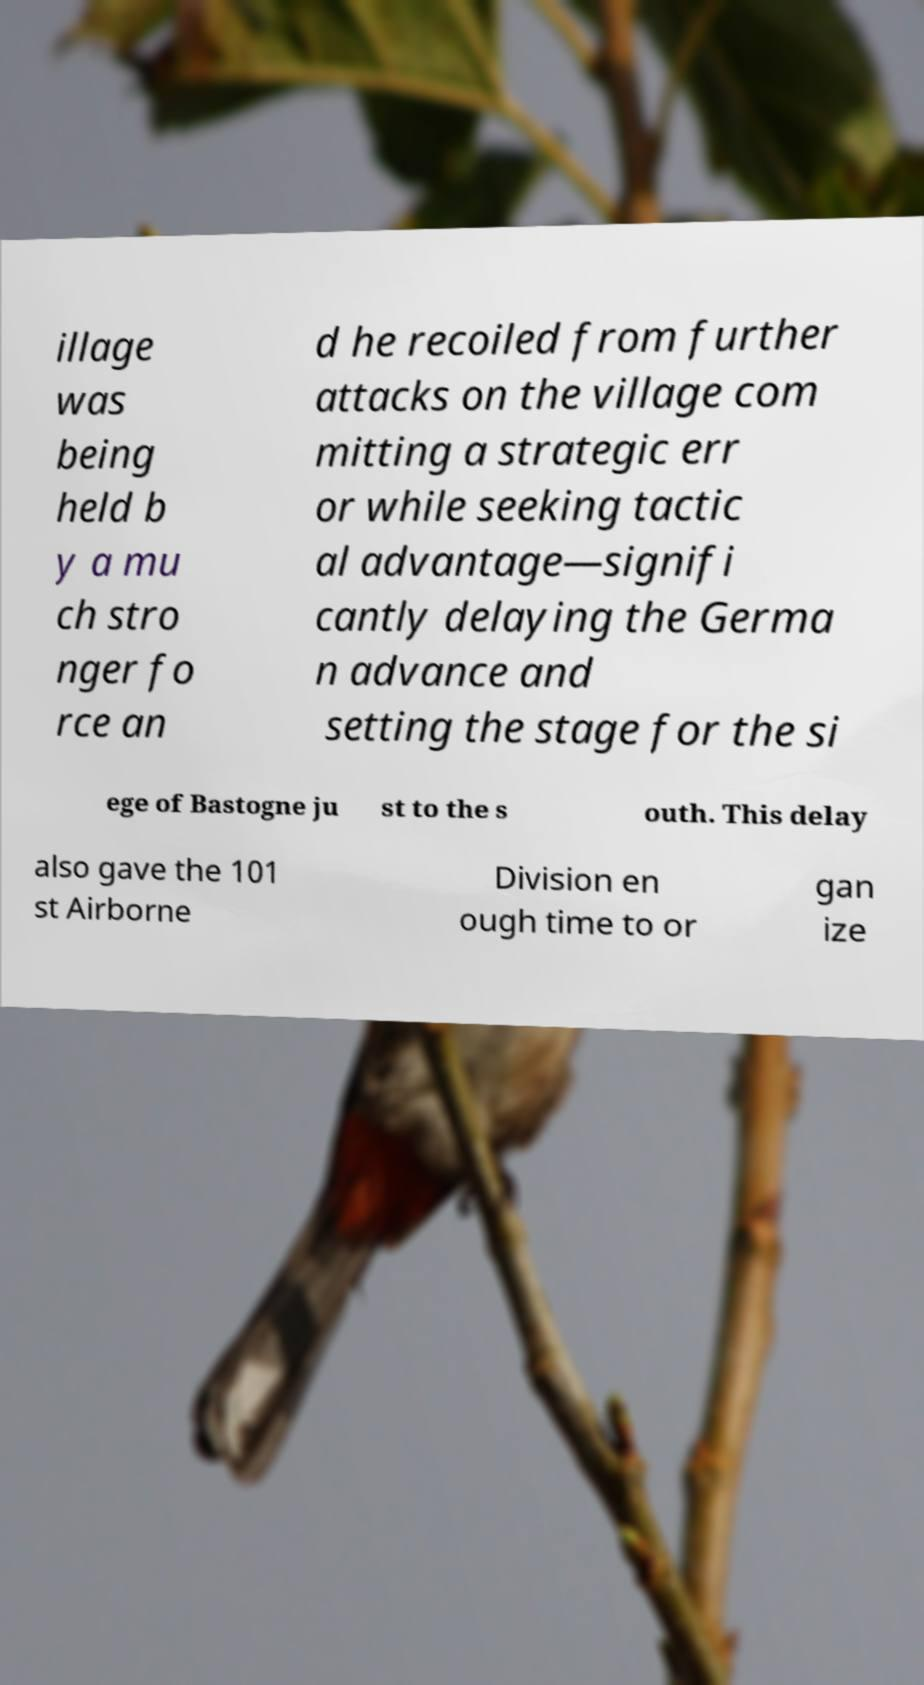I need the written content from this picture converted into text. Can you do that? illage was being held b y a mu ch stro nger fo rce an d he recoiled from further attacks on the village com mitting a strategic err or while seeking tactic al advantage—signifi cantly delaying the Germa n advance and setting the stage for the si ege of Bastogne ju st to the s outh. This delay also gave the 101 st Airborne Division en ough time to or gan ize 